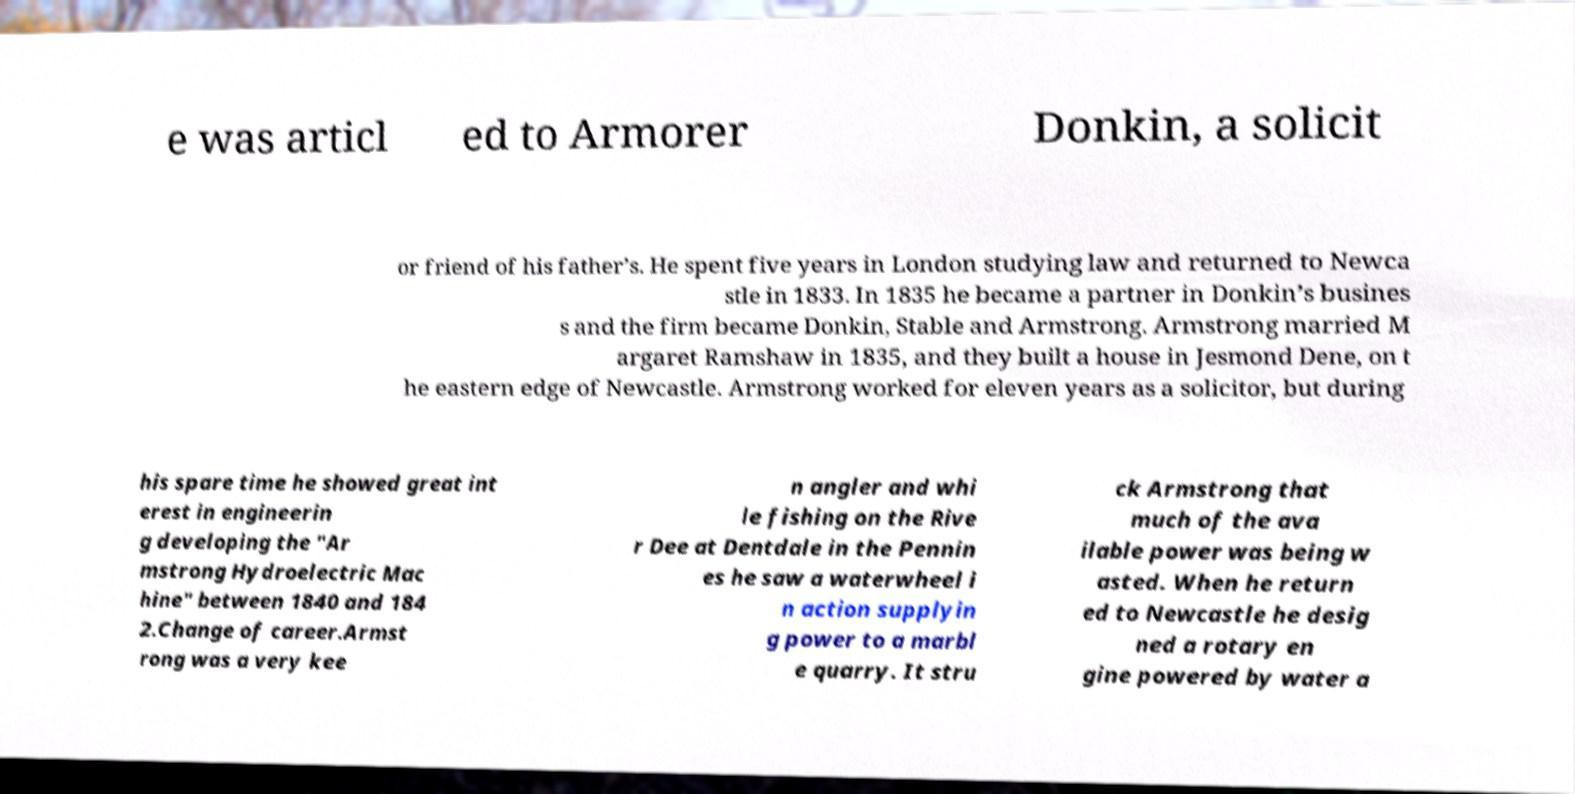There's text embedded in this image that I need extracted. Can you transcribe it verbatim? e was articl ed to Armorer Donkin, a solicit or friend of his father’s. He spent five years in London studying law and returned to Newca stle in 1833. In 1835 he became a partner in Donkin’s busines s and the firm became Donkin, Stable and Armstrong. Armstrong married M argaret Ramshaw in 1835, and they built a house in Jesmond Dene, on t he eastern edge of Newcastle. Armstrong worked for eleven years as a solicitor, but during his spare time he showed great int erest in engineerin g developing the "Ar mstrong Hydroelectric Mac hine" between 1840 and 184 2.Change of career.Armst rong was a very kee n angler and whi le fishing on the Rive r Dee at Dentdale in the Pennin es he saw a waterwheel i n action supplyin g power to a marbl e quarry. It stru ck Armstrong that much of the ava ilable power was being w asted. When he return ed to Newcastle he desig ned a rotary en gine powered by water a 